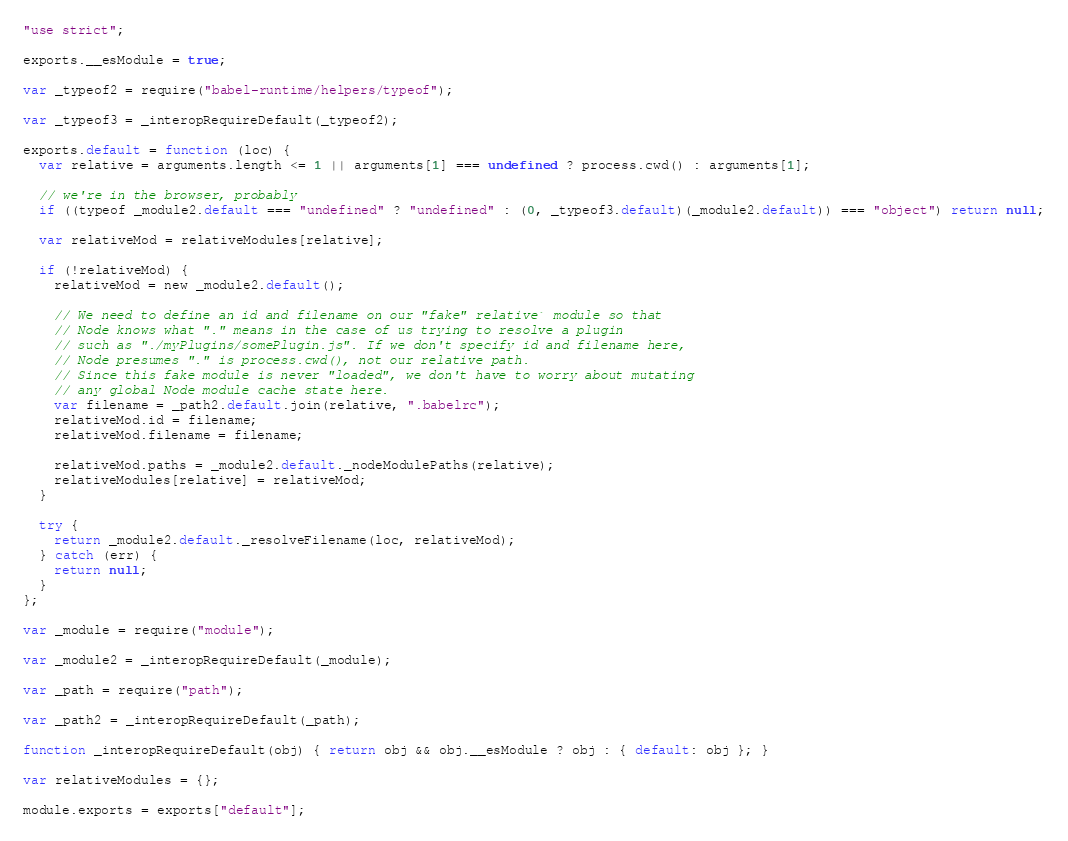Convert code to text. <code><loc_0><loc_0><loc_500><loc_500><_JavaScript_>"use strict";

exports.__esModule = true;

var _typeof2 = require("babel-runtime/helpers/typeof");

var _typeof3 = _interopRequireDefault(_typeof2);

exports.default = function (loc) {
  var relative = arguments.length <= 1 || arguments[1] === undefined ? process.cwd() : arguments[1];

  // we're in the browser, probably
  if ((typeof _module2.default === "undefined" ? "undefined" : (0, _typeof3.default)(_module2.default)) === "object") return null;

  var relativeMod = relativeModules[relative];

  if (!relativeMod) {
    relativeMod = new _module2.default();

    // We need to define an id and filename on our "fake" relative` module so that
    // Node knows what "." means in the case of us trying to resolve a plugin
    // such as "./myPlugins/somePlugin.js". If we don't specify id and filename here,
    // Node presumes "." is process.cwd(), not our relative path.
    // Since this fake module is never "loaded", we don't have to worry about mutating
    // any global Node module cache state here.
    var filename = _path2.default.join(relative, ".babelrc");
    relativeMod.id = filename;
    relativeMod.filename = filename;

    relativeMod.paths = _module2.default._nodeModulePaths(relative);
    relativeModules[relative] = relativeMod;
  }

  try {
    return _module2.default._resolveFilename(loc, relativeMod);
  } catch (err) {
    return null;
  }
};

var _module = require("module");

var _module2 = _interopRequireDefault(_module);

var _path = require("path");

var _path2 = _interopRequireDefault(_path);

function _interopRequireDefault(obj) { return obj && obj.__esModule ? obj : { default: obj }; }

var relativeModules = {};

module.exports = exports["default"];</code> 